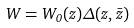Convert formula to latex. <formula><loc_0><loc_0><loc_500><loc_500>W = W _ { 0 } ( z ) \Delta ( z , { \bar { z } } )</formula> 